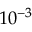Convert formula to latex. <formula><loc_0><loc_0><loc_500><loc_500>1 0 ^ { - 3 }</formula> 